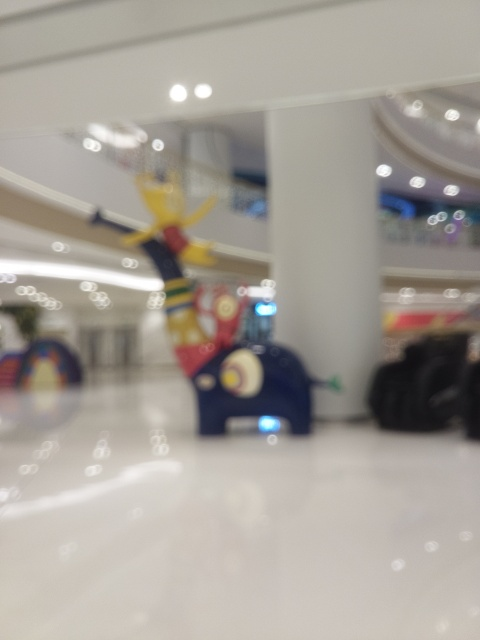What kind of setting is this image depicting, and how can you tell despite the blurriness? The image appears to capture an indoor setting, likely a shopping mall or similar commercial space, indicated by the bright artificial lighting and the presence of retail store facades in the background. There is a colorful structure in the center of the frame which seems to be part of a playful art installation, typical of modern mall interiors designed to attract and engage visitors. 